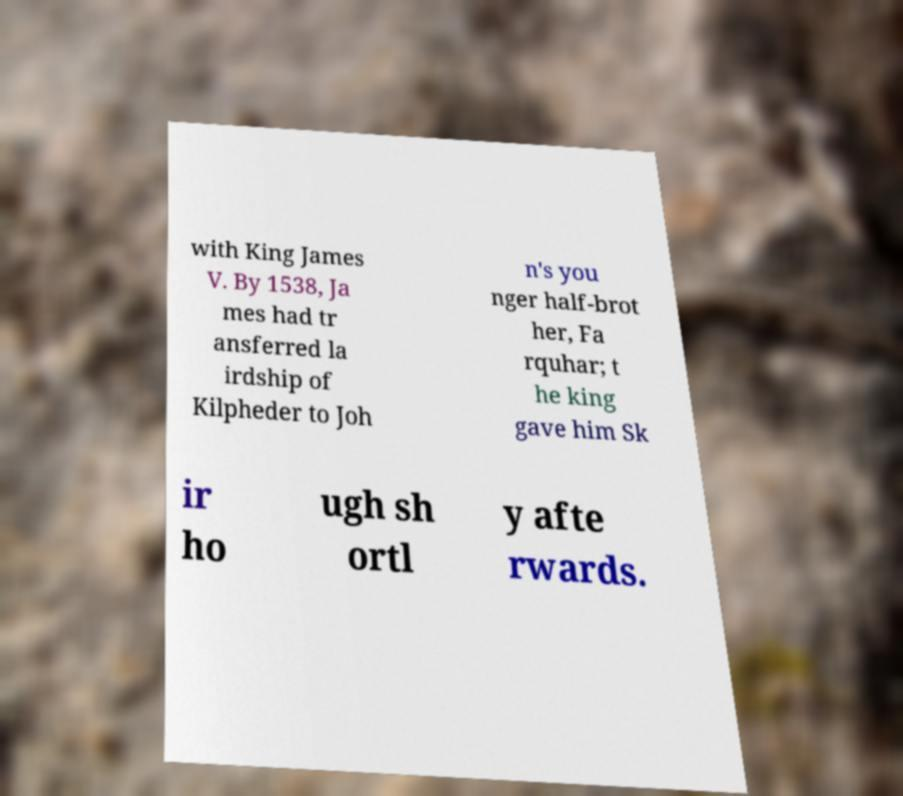What messages or text are displayed in this image? I need them in a readable, typed format. with King James V. By 1538, Ja mes had tr ansferred la irdship of Kilpheder to Joh n's you nger half-brot her, Fa rquhar; t he king gave him Sk ir ho ugh sh ortl y afte rwards. 